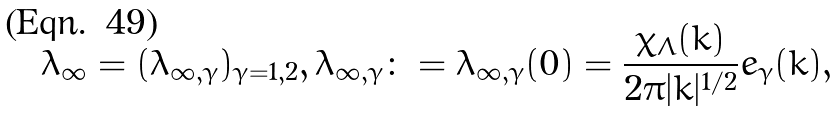<formula> <loc_0><loc_0><loc_500><loc_500>\lambda _ { \infty } = ( \lambda _ { \infty , \gamma } ) _ { \gamma = 1 , 2 } , \lambda _ { \infty , \gamma } \colon = \lambda _ { \infty , \gamma } ( 0 ) = \frac { \chi _ { \Lambda } ( k ) } { 2 \pi | k | ^ { 1 / 2 } } e _ { \gamma } ( k ) ,</formula> 